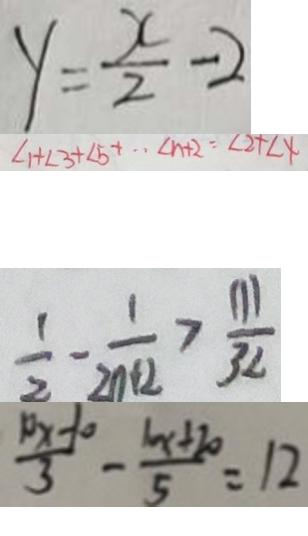Convert formula to latex. <formula><loc_0><loc_0><loc_500><loc_500>y = \frac { x } { 2 } - 2 
 1 + \angle 3 + \angle 5 + \cdots \angle n + 2 = \angle 2 + \angle 4 
 \frac { 1 } { 2 } - \frac { 1 } { 2 n + 2 } > \frac { 1 1 1 } { 3 2 } 
 \frac { 1 0 x - 1 0 } { 3 } - \frac { 1 0 x + 2 0 } { 5 } = 1 2</formula> 